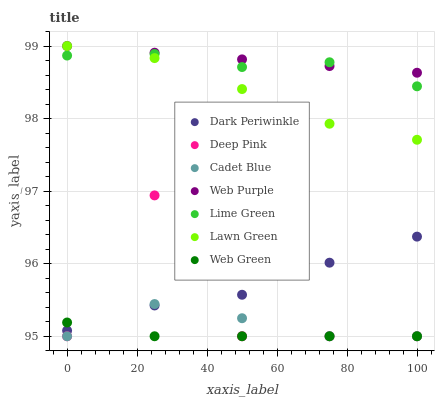Does Web Green have the minimum area under the curve?
Answer yes or no. Yes. Does Web Purple have the maximum area under the curve?
Answer yes or no. Yes. Does Cadet Blue have the minimum area under the curve?
Answer yes or no. No. Does Cadet Blue have the maximum area under the curve?
Answer yes or no. No. Is Web Purple the smoothest?
Answer yes or no. Yes. Is Deep Pink the roughest?
Answer yes or no. Yes. Is Cadet Blue the smoothest?
Answer yes or no. No. Is Cadet Blue the roughest?
Answer yes or no. No. Does Cadet Blue have the lowest value?
Answer yes or no. Yes. Does Web Purple have the lowest value?
Answer yes or no. No. Does Web Purple have the highest value?
Answer yes or no. Yes. Does Cadet Blue have the highest value?
Answer yes or no. No. Is Dark Periwinkle less than Lawn Green?
Answer yes or no. Yes. Is Lime Green greater than Deep Pink?
Answer yes or no. Yes. Does Deep Pink intersect Cadet Blue?
Answer yes or no. Yes. Is Deep Pink less than Cadet Blue?
Answer yes or no. No. Is Deep Pink greater than Cadet Blue?
Answer yes or no. No. Does Dark Periwinkle intersect Lawn Green?
Answer yes or no. No. 